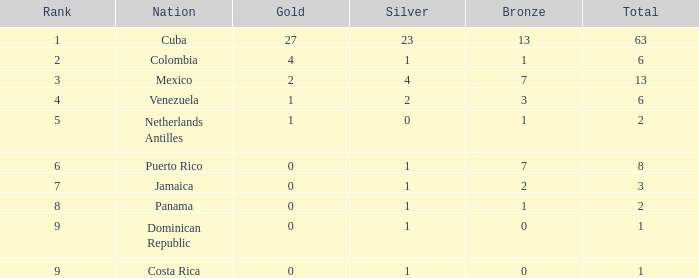What nation has the lowest gold average that has a rank over 9? None. 